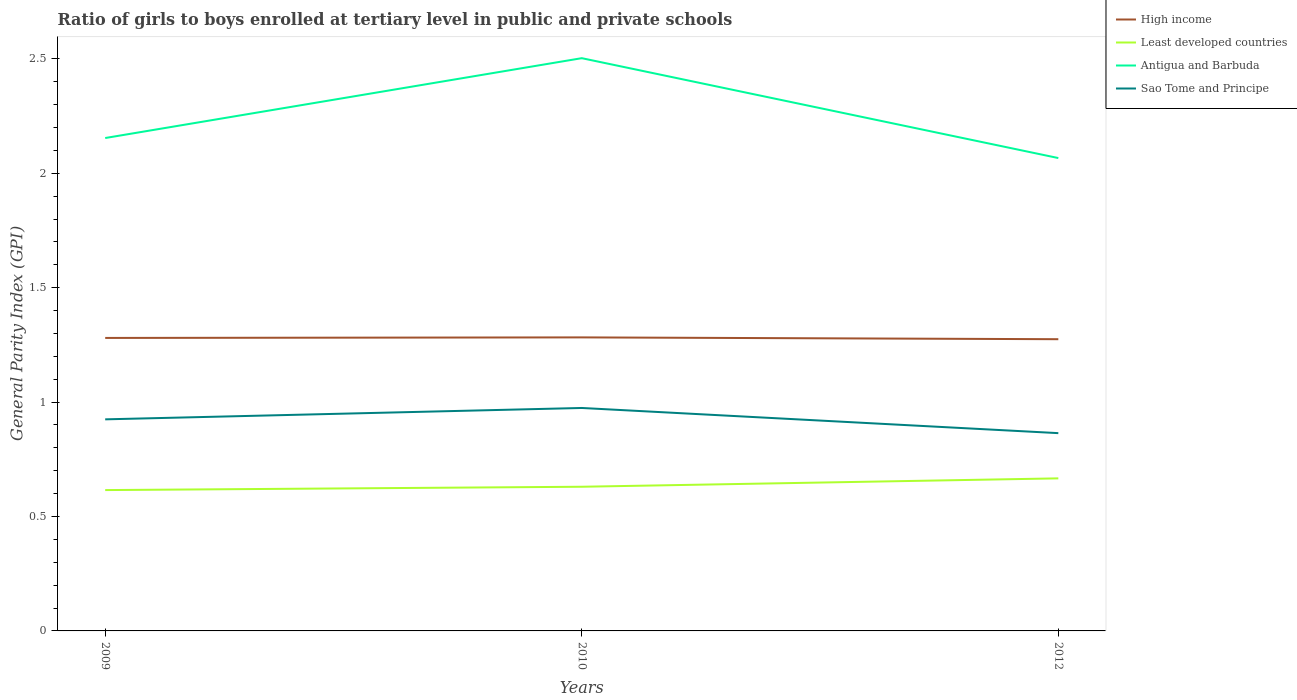Across all years, what is the maximum general parity index in Sao Tome and Principe?
Offer a very short reply. 0.86. What is the total general parity index in Least developed countries in the graph?
Provide a short and direct response. -0.05. What is the difference between the highest and the second highest general parity index in Least developed countries?
Make the answer very short. 0.05. Is the general parity index in Sao Tome and Principe strictly greater than the general parity index in Antigua and Barbuda over the years?
Keep it short and to the point. Yes. How many years are there in the graph?
Provide a succinct answer. 3. What is the difference between two consecutive major ticks on the Y-axis?
Provide a succinct answer. 0.5. Are the values on the major ticks of Y-axis written in scientific E-notation?
Give a very brief answer. No. Where does the legend appear in the graph?
Your answer should be very brief. Top right. What is the title of the graph?
Keep it short and to the point. Ratio of girls to boys enrolled at tertiary level in public and private schools. Does "Equatorial Guinea" appear as one of the legend labels in the graph?
Your answer should be compact. No. What is the label or title of the Y-axis?
Make the answer very short. General Parity Index (GPI). What is the General Parity Index (GPI) of High income in 2009?
Provide a short and direct response. 1.28. What is the General Parity Index (GPI) in Least developed countries in 2009?
Give a very brief answer. 0.62. What is the General Parity Index (GPI) of Antigua and Barbuda in 2009?
Provide a short and direct response. 2.15. What is the General Parity Index (GPI) in Sao Tome and Principe in 2009?
Your response must be concise. 0.92. What is the General Parity Index (GPI) in High income in 2010?
Give a very brief answer. 1.28. What is the General Parity Index (GPI) of Least developed countries in 2010?
Provide a short and direct response. 0.63. What is the General Parity Index (GPI) in Antigua and Barbuda in 2010?
Your response must be concise. 2.5. What is the General Parity Index (GPI) in Sao Tome and Principe in 2010?
Keep it short and to the point. 0.97. What is the General Parity Index (GPI) of High income in 2012?
Your answer should be compact. 1.27. What is the General Parity Index (GPI) in Least developed countries in 2012?
Your answer should be very brief. 0.67. What is the General Parity Index (GPI) of Antigua and Barbuda in 2012?
Give a very brief answer. 2.07. What is the General Parity Index (GPI) of Sao Tome and Principe in 2012?
Offer a very short reply. 0.86. Across all years, what is the maximum General Parity Index (GPI) of High income?
Give a very brief answer. 1.28. Across all years, what is the maximum General Parity Index (GPI) of Least developed countries?
Ensure brevity in your answer.  0.67. Across all years, what is the maximum General Parity Index (GPI) of Antigua and Barbuda?
Give a very brief answer. 2.5. Across all years, what is the maximum General Parity Index (GPI) in Sao Tome and Principe?
Offer a terse response. 0.97. Across all years, what is the minimum General Parity Index (GPI) of High income?
Make the answer very short. 1.27. Across all years, what is the minimum General Parity Index (GPI) of Least developed countries?
Keep it short and to the point. 0.62. Across all years, what is the minimum General Parity Index (GPI) in Antigua and Barbuda?
Your answer should be very brief. 2.07. Across all years, what is the minimum General Parity Index (GPI) of Sao Tome and Principe?
Keep it short and to the point. 0.86. What is the total General Parity Index (GPI) of High income in the graph?
Offer a terse response. 3.84. What is the total General Parity Index (GPI) in Least developed countries in the graph?
Provide a short and direct response. 1.91. What is the total General Parity Index (GPI) of Antigua and Barbuda in the graph?
Provide a short and direct response. 6.72. What is the total General Parity Index (GPI) in Sao Tome and Principe in the graph?
Ensure brevity in your answer.  2.76. What is the difference between the General Parity Index (GPI) of High income in 2009 and that in 2010?
Provide a short and direct response. -0. What is the difference between the General Parity Index (GPI) in Least developed countries in 2009 and that in 2010?
Your response must be concise. -0.01. What is the difference between the General Parity Index (GPI) of Antigua and Barbuda in 2009 and that in 2010?
Give a very brief answer. -0.35. What is the difference between the General Parity Index (GPI) in Sao Tome and Principe in 2009 and that in 2010?
Offer a terse response. -0.05. What is the difference between the General Parity Index (GPI) of High income in 2009 and that in 2012?
Your answer should be very brief. 0.01. What is the difference between the General Parity Index (GPI) of Least developed countries in 2009 and that in 2012?
Offer a very short reply. -0.05. What is the difference between the General Parity Index (GPI) of Antigua and Barbuda in 2009 and that in 2012?
Your answer should be very brief. 0.09. What is the difference between the General Parity Index (GPI) of Sao Tome and Principe in 2009 and that in 2012?
Your response must be concise. 0.06. What is the difference between the General Parity Index (GPI) of High income in 2010 and that in 2012?
Provide a succinct answer. 0.01. What is the difference between the General Parity Index (GPI) of Least developed countries in 2010 and that in 2012?
Offer a terse response. -0.04. What is the difference between the General Parity Index (GPI) of Antigua and Barbuda in 2010 and that in 2012?
Ensure brevity in your answer.  0.44. What is the difference between the General Parity Index (GPI) of Sao Tome and Principe in 2010 and that in 2012?
Your answer should be compact. 0.11. What is the difference between the General Parity Index (GPI) in High income in 2009 and the General Parity Index (GPI) in Least developed countries in 2010?
Provide a short and direct response. 0.65. What is the difference between the General Parity Index (GPI) in High income in 2009 and the General Parity Index (GPI) in Antigua and Barbuda in 2010?
Your answer should be compact. -1.22. What is the difference between the General Parity Index (GPI) of High income in 2009 and the General Parity Index (GPI) of Sao Tome and Principe in 2010?
Keep it short and to the point. 0.31. What is the difference between the General Parity Index (GPI) of Least developed countries in 2009 and the General Parity Index (GPI) of Antigua and Barbuda in 2010?
Make the answer very short. -1.89. What is the difference between the General Parity Index (GPI) in Least developed countries in 2009 and the General Parity Index (GPI) in Sao Tome and Principe in 2010?
Make the answer very short. -0.36. What is the difference between the General Parity Index (GPI) in Antigua and Barbuda in 2009 and the General Parity Index (GPI) in Sao Tome and Principe in 2010?
Make the answer very short. 1.18. What is the difference between the General Parity Index (GPI) in High income in 2009 and the General Parity Index (GPI) in Least developed countries in 2012?
Ensure brevity in your answer.  0.61. What is the difference between the General Parity Index (GPI) of High income in 2009 and the General Parity Index (GPI) of Antigua and Barbuda in 2012?
Ensure brevity in your answer.  -0.79. What is the difference between the General Parity Index (GPI) in High income in 2009 and the General Parity Index (GPI) in Sao Tome and Principe in 2012?
Your answer should be very brief. 0.42. What is the difference between the General Parity Index (GPI) in Least developed countries in 2009 and the General Parity Index (GPI) in Antigua and Barbuda in 2012?
Keep it short and to the point. -1.45. What is the difference between the General Parity Index (GPI) of Least developed countries in 2009 and the General Parity Index (GPI) of Sao Tome and Principe in 2012?
Your response must be concise. -0.25. What is the difference between the General Parity Index (GPI) in Antigua and Barbuda in 2009 and the General Parity Index (GPI) in Sao Tome and Principe in 2012?
Make the answer very short. 1.29. What is the difference between the General Parity Index (GPI) of High income in 2010 and the General Parity Index (GPI) of Least developed countries in 2012?
Your answer should be very brief. 0.62. What is the difference between the General Parity Index (GPI) of High income in 2010 and the General Parity Index (GPI) of Antigua and Barbuda in 2012?
Offer a terse response. -0.78. What is the difference between the General Parity Index (GPI) of High income in 2010 and the General Parity Index (GPI) of Sao Tome and Principe in 2012?
Your answer should be compact. 0.42. What is the difference between the General Parity Index (GPI) in Least developed countries in 2010 and the General Parity Index (GPI) in Antigua and Barbuda in 2012?
Provide a succinct answer. -1.44. What is the difference between the General Parity Index (GPI) in Least developed countries in 2010 and the General Parity Index (GPI) in Sao Tome and Principe in 2012?
Keep it short and to the point. -0.23. What is the difference between the General Parity Index (GPI) of Antigua and Barbuda in 2010 and the General Parity Index (GPI) of Sao Tome and Principe in 2012?
Give a very brief answer. 1.64. What is the average General Parity Index (GPI) in High income per year?
Your answer should be very brief. 1.28. What is the average General Parity Index (GPI) in Least developed countries per year?
Your response must be concise. 0.64. What is the average General Parity Index (GPI) of Antigua and Barbuda per year?
Give a very brief answer. 2.24. What is the average General Parity Index (GPI) of Sao Tome and Principe per year?
Your response must be concise. 0.92. In the year 2009, what is the difference between the General Parity Index (GPI) of High income and General Parity Index (GPI) of Least developed countries?
Offer a terse response. 0.66. In the year 2009, what is the difference between the General Parity Index (GPI) of High income and General Parity Index (GPI) of Antigua and Barbuda?
Your answer should be compact. -0.87. In the year 2009, what is the difference between the General Parity Index (GPI) of High income and General Parity Index (GPI) of Sao Tome and Principe?
Keep it short and to the point. 0.36. In the year 2009, what is the difference between the General Parity Index (GPI) of Least developed countries and General Parity Index (GPI) of Antigua and Barbuda?
Your answer should be compact. -1.54. In the year 2009, what is the difference between the General Parity Index (GPI) in Least developed countries and General Parity Index (GPI) in Sao Tome and Principe?
Keep it short and to the point. -0.31. In the year 2009, what is the difference between the General Parity Index (GPI) in Antigua and Barbuda and General Parity Index (GPI) in Sao Tome and Principe?
Provide a succinct answer. 1.23. In the year 2010, what is the difference between the General Parity Index (GPI) of High income and General Parity Index (GPI) of Least developed countries?
Your answer should be compact. 0.65. In the year 2010, what is the difference between the General Parity Index (GPI) of High income and General Parity Index (GPI) of Antigua and Barbuda?
Offer a terse response. -1.22. In the year 2010, what is the difference between the General Parity Index (GPI) of High income and General Parity Index (GPI) of Sao Tome and Principe?
Keep it short and to the point. 0.31. In the year 2010, what is the difference between the General Parity Index (GPI) of Least developed countries and General Parity Index (GPI) of Antigua and Barbuda?
Your answer should be compact. -1.87. In the year 2010, what is the difference between the General Parity Index (GPI) in Least developed countries and General Parity Index (GPI) in Sao Tome and Principe?
Keep it short and to the point. -0.34. In the year 2010, what is the difference between the General Parity Index (GPI) in Antigua and Barbuda and General Parity Index (GPI) in Sao Tome and Principe?
Make the answer very short. 1.53. In the year 2012, what is the difference between the General Parity Index (GPI) in High income and General Parity Index (GPI) in Least developed countries?
Your answer should be compact. 0.61. In the year 2012, what is the difference between the General Parity Index (GPI) of High income and General Parity Index (GPI) of Antigua and Barbuda?
Offer a terse response. -0.79. In the year 2012, what is the difference between the General Parity Index (GPI) in High income and General Parity Index (GPI) in Sao Tome and Principe?
Your response must be concise. 0.41. In the year 2012, what is the difference between the General Parity Index (GPI) of Least developed countries and General Parity Index (GPI) of Antigua and Barbuda?
Keep it short and to the point. -1.4. In the year 2012, what is the difference between the General Parity Index (GPI) in Least developed countries and General Parity Index (GPI) in Sao Tome and Principe?
Keep it short and to the point. -0.2. In the year 2012, what is the difference between the General Parity Index (GPI) in Antigua and Barbuda and General Parity Index (GPI) in Sao Tome and Principe?
Ensure brevity in your answer.  1.2. What is the ratio of the General Parity Index (GPI) in High income in 2009 to that in 2010?
Your answer should be compact. 1. What is the ratio of the General Parity Index (GPI) of Antigua and Barbuda in 2009 to that in 2010?
Provide a short and direct response. 0.86. What is the ratio of the General Parity Index (GPI) of Sao Tome and Principe in 2009 to that in 2010?
Give a very brief answer. 0.95. What is the ratio of the General Parity Index (GPI) in High income in 2009 to that in 2012?
Ensure brevity in your answer.  1. What is the ratio of the General Parity Index (GPI) in Least developed countries in 2009 to that in 2012?
Provide a short and direct response. 0.92. What is the ratio of the General Parity Index (GPI) in Antigua and Barbuda in 2009 to that in 2012?
Your answer should be compact. 1.04. What is the ratio of the General Parity Index (GPI) in Sao Tome and Principe in 2009 to that in 2012?
Your response must be concise. 1.07. What is the ratio of the General Parity Index (GPI) in Least developed countries in 2010 to that in 2012?
Provide a short and direct response. 0.94. What is the ratio of the General Parity Index (GPI) in Antigua and Barbuda in 2010 to that in 2012?
Your answer should be compact. 1.21. What is the ratio of the General Parity Index (GPI) in Sao Tome and Principe in 2010 to that in 2012?
Your answer should be very brief. 1.13. What is the difference between the highest and the second highest General Parity Index (GPI) in High income?
Keep it short and to the point. 0. What is the difference between the highest and the second highest General Parity Index (GPI) in Least developed countries?
Provide a short and direct response. 0.04. What is the difference between the highest and the second highest General Parity Index (GPI) of Antigua and Barbuda?
Provide a succinct answer. 0.35. What is the difference between the highest and the second highest General Parity Index (GPI) of Sao Tome and Principe?
Ensure brevity in your answer.  0.05. What is the difference between the highest and the lowest General Parity Index (GPI) in High income?
Your answer should be very brief. 0.01. What is the difference between the highest and the lowest General Parity Index (GPI) in Least developed countries?
Provide a succinct answer. 0.05. What is the difference between the highest and the lowest General Parity Index (GPI) of Antigua and Barbuda?
Your answer should be very brief. 0.44. What is the difference between the highest and the lowest General Parity Index (GPI) of Sao Tome and Principe?
Offer a terse response. 0.11. 